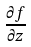Convert formula to latex. <formula><loc_0><loc_0><loc_500><loc_500>\frac { \partial f } { \partial z }</formula> 